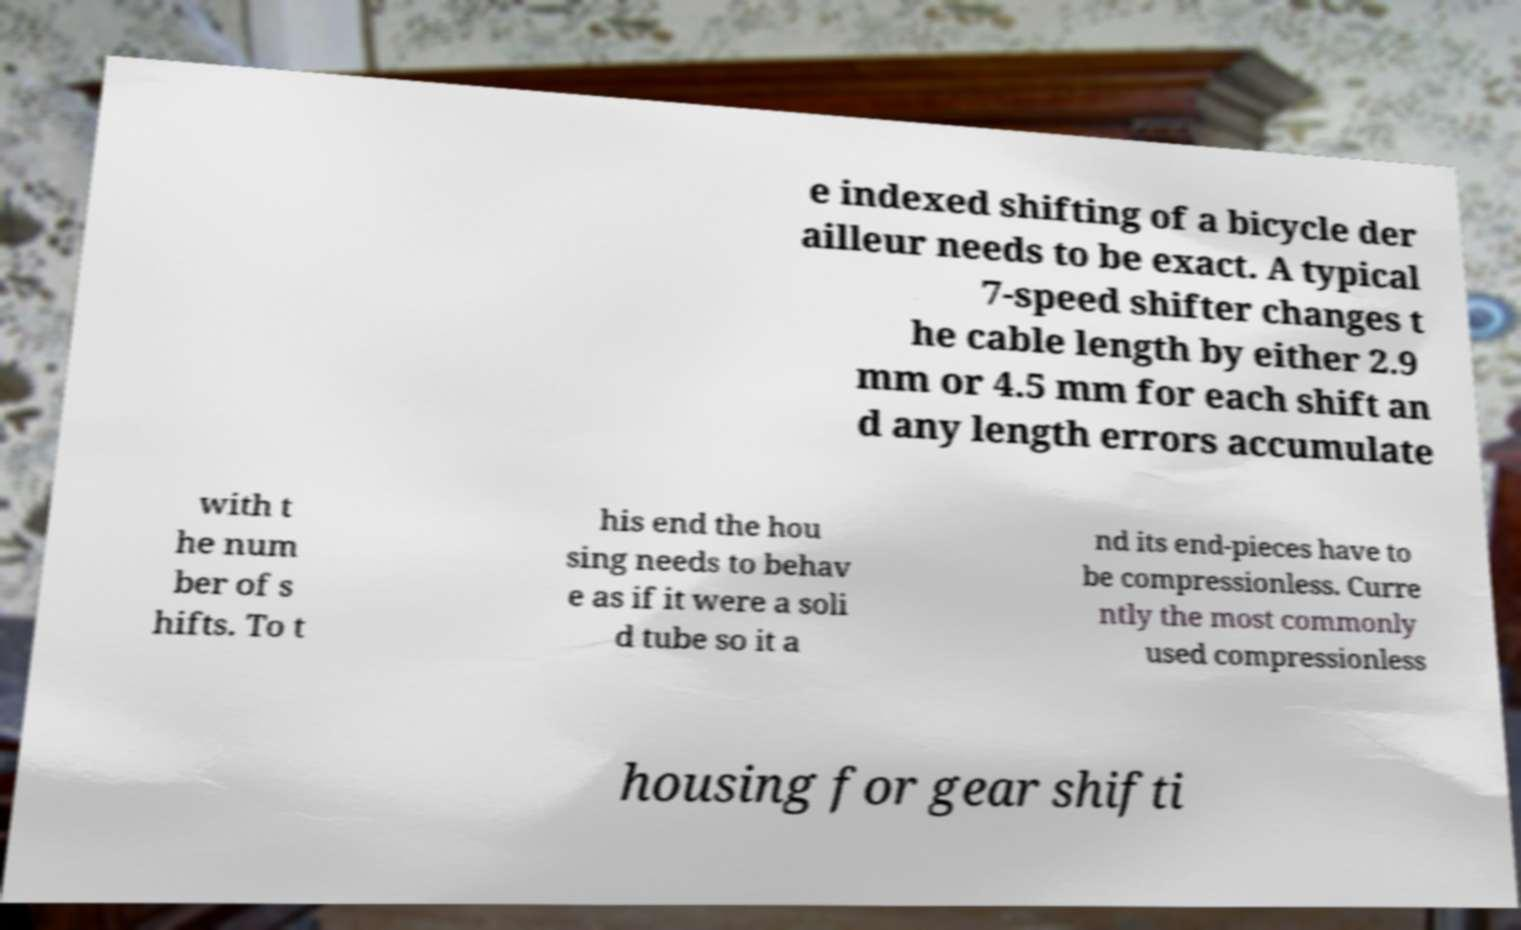Please identify and transcribe the text found in this image. e indexed shifting of a bicycle der ailleur needs to be exact. A typical 7-speed shifter changes t he cable length by either 2.9 mm or 4.5 mm for each shift an d any length errors accumulate with t he num ber of s hifts. To t his end the hou sing needs to behav e as if it were a soli d tube so it a nd its end-pieces have to be compressionless. Curre ntly the most commonly used compressionless housing for gear shifti 